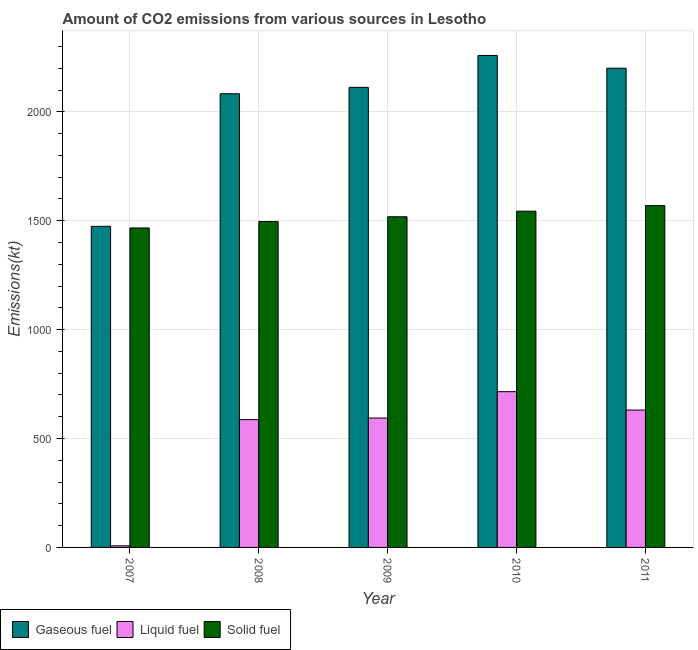How many different coloured bars are there?
Your response must be concise. 3. Are the number of bars on each tick of the X-axis equal?
Offer a very short reply. Yes. How many bars are there on the 2nd tick from the left?
Provide a succinct answer. 3. What is the label of the 3rd group of bars from the left?
Make the answer very short. 2009. In how many cases, is the number of bars for a given year not equal to the number of legend labels?
Offer a very short reply. 0. What is the amount of co2 emissions from gaseous fuel in 2010?
Ensure brevity in your answer.  2258.87. Across all years, what is the maximum amount of co2 emissions from gaseous fuel?
Offer a terse response. 2258.87. Across all years, what is the minimum amount of co2 emissions from solid fuel?
Keep it short and to the point. 1466.8. In which year was the amount of co2 emissions from solid fuel maximum?
Make the answer very short. 2011. What is the total amount of co2 emissions from liquid fuel in the graph?
Your answer should be very brief. 2533.9. What is the difference between the amount of co2 emissions from liquid fuel in 2007 and that in 2010?
Your answer should be very brief. -707.73. What is the difference between the amount of co2 emissions from liquid fuel in 2010 and the amount of co2 emissions from gaseous fuel in 2008?
Make the answer very short. 128.35. What is the average amount of co2 emissions from gaseous fuel per year?
Give a very brief answer. 2025.65. In the year 2008, what is the difference between the amount of co2 emissions from liquid fuel and amount of co2 emissions from solid fuel?
Your answer should be compact. 0. What is the ratio of the amount of co2 emissions from liquid fuel in 2007 to that in 2008?
Your answer should be very brief. 0.01. What is the difference between the highest and the second highest amount of co2 emissions from solid fuel?
Offer a very short reply. 25.67. What is the difference between the highest and the lowest amount of co2 emissions from gaseous fuel?
Provide a succinct answer. 784.74. Is the sum of the amount of co2 emissions from liquid fuel in 2008 and 2011 greater than the maximum amount of co2 emissions from gaseous fuel across all years?
Make the answer very short. Yes. What does the 3rd bar from the left in 2009 represents?
Offer a terse response. Solid fuel. What does the 3rd bar from the right in 2011 represents?
Ensure brevity in your answer.  Gaseous fuel. How many bars are there?
Your answer should be very brief. 15. Are all the bars in the graph horizontal?
Offer a terse response. No. What is the difference between two consecutive major ticks on the Y-axis?
Provide a short and direct response. 500. Does the graph contain any zero values?
Make the answer very short. No. Does the graph contain grids?
Provide a short and direct response. Yes. Where does the legend appear in the graph?
Make the answer very short. Bottom left. How are the legend labels stacked?
Provide a short and direct response. Horizontal. What is the title of the graph?
Offer a very short reply. Amount of CO2 emissions from various sources in Lesotho. Does "Non-communicable diseases" appear as one of the legend labels in the graph?
Offer a terse response. No. What is the label or title of the Y-axis?
Keep it short and to the point. Emissions(kt). What is the Emissions(kt) of Gaseous fuel in 2007?
Your answer should be compact. 1474.13. What is the Emissions(kt) of Liquid fuel in 2007?
Keep it short and to the point. 7.33. What is the Emissions(kt) in Solid fuel in 2007?
Provide a succinct answer. 1466.8. What is the Emissions(kt) in Gaseous fuel in 2008?
Keep it short and to the point. 2082.86. What is the Emissions(kt) in Liquid fuel in 2008?
Offer a terse response. 586.72. What is the Emissions(kt) of Solid fuel in 2008?
Provide a succinct answer. 1496.14. What is the Emissions(kt) in Gaseous fuel in 2009?
Your answer should be compact. 2112.19. What is the Emissions(kt) of Liquid fuel in 2009?
Your answer should be very brief. 594.05. What is the Emissions(kt) of Solid fuel in 2009?
Your answer should be compact. 1518.14. What is the Emissions(kt) of Gaseous fuel in 2010?
Give a very brief answer. 2258.87. What is the Emissions(kt) of Liquid fuel in 2010?
Your answer should be compact. 715.07. What is the Emissions(kt) of Solid fuel in 2010?
Provide a short and direct response. 1543.81. What is the Emissions(kt) of Gaseous fuel in 2011?
Offer a very short reply. 2200.2. What is the Emissions(kt) of Liquid fuel in 2011?
Give a very brief answer. 630.72. What is the Emissions(kt) of Solid fuel in 2011?
Provide a succinct answer. 1569.48. Across all years, what is the maximum Emissions(kt) in Gaseous fuel?
Make the answer very short. 2258.87. Across all years, what is the maximum Emissions(kt) of Liquid fuel?
Ensure brevity in your answer.  715.07. Across all years, what is the maximum Emissions(kt) in Solid fuel?
Provide a short and direct response. 1569.48. Across all years, what is the minimum Emissions(kt) of Gaseous fuel?
Your answer should be compact. 1474.13. Across all years, what is the minimum Emissions(kt) of Liquid fuel?
Offer a very short reply. 7.33. Across all years, what is the minimum Emissions(kt) in Solid fuel?
Ensure brevity in your answer.  1466.8. What is the total Emissions(kt) of Gaseous fuel in the graph?
Your answer should be very brief. 1.01e+04. What is the total Emissions(kt) of Liquid fuel in the graph?
Make the answer very short. 2533.9. What is the total Emissions(kt) of Solid fuel in the graph?
Provide a short and direct response. 7594.36. What is the difference between the Emissions(kt) of Gaseous fuel in 2007 and that in 2008?
Make the answer very short. -608.72. What is the difference between the Emissions(kt) of Liquid fuel in 2007 and that in 2008?
Offer a very short reply. -579.39. What is the difference between the Emissions(kt) in Solid fuel in 2007 and that in 2008?
Provide a short and direct response. -29.34. What is the difference between the Emissions(kt) in Gaseous fuel in 2007 and that in 2009?
Provide a succinct answer. -638.06. What is the difference between the Emissions(kt) of Liquid fuel in 2007 and that in 2009?
Your response must be concise. -586.72. What is the difference between the Emissions(kt) of Solid fuel in 2007 and that in 2009?
Make the answer very short. -51.34. What is the difference between the Emissions(kt) in Gaseous fuel in 2007 and that in 2010?
Give a very brief answer. -784.74. What is the difference between the Emissions(kt) in Liquid fuel in 2007 and that in 2010?
Your response must be concise. -707.73. What is the difference between the Emissions(kt) in Solid fuel in 2007 and that in 2010?
Provide a short and direct response. -77.01. What is the difference between the Emissions(kt) in Gaseous fuel in 2007 and that in 2011?
Make the answer very short. -726.07. What is the difference between the Emissions(kt) in Liquid fuel in 2007 and that in 2011?
Your response must be concise. -623.39. What is the difference between the Emissions(kt) of Solid fuel in 2007 and that in 2011?
Provide a succinct answer. -102.68. What is the difference between the Emissions(kt) of Gaseous fuel in 2008 and that in 2009?
Your answer should be compact. -29.34. What is the difference between the Emissions(kt) of Liquid fuel in 2008 and that in 2009?
Your response must be concise. -7.33. What is the difference between the Emissions(kt) of Solid fuel in 2008 and that in 2009?
Make the answer very short. -22. What is the difference between the Emissions(kt) in Gaseous fuel in 2008 and that in 2010?
Give a very brief answer. -176.02. What is the difference between the Emissions(kt) of Liquid fuel in 2008 and that in 2010?
Ensure brevity in your answer.  -128.34. What is the difference between the Emissions(kt) in Solid fuel in 2008 and that in 2010?
Keep it short and to the point. -47.67. What is the difference between the Emissions(kt) of Gaseous fuel in 2008 and that in 2011?
Ensure brevity in your answer.  -117.34. What is the difference between the Emissions(kt) of Liquid fuel in 2008 and that in 2011?
Make the answer very short. -44. What is the difference between the Emissions(kt) in Solid fuel in 2008 and that in 2011?
Your response must be concise. -73.34. What is the difference between the Emissions(kt) of Gaseous fuel in 2009 and that in 2010?
Provide a succinct answer. -146.68. What is the difference between the Emissions(kt) of Liquid fuel in 2009 and that in 2010?
Give a very brief answer. -121.01. What is the difference between the Emissions(kt) in Solid fuel in 2009 and that in 2010?
Ensure brevity in your answer.  -25.67. What is the difference between the Emissions(kt) of Gaseous fuel in 2009 and that in 2011?
Give a very brief answer. -88.01. What is the difference between the Emissions(kt) in Liquid fuel in 2009 and that in 2011?
Ensure brevity in your answer.  -36.67. What is the difference between the Emissions(kt) in Solid fuel in 2009 and that in 2011?
Provide a succinct answer. -51.34. What is the difference between the Emissions(kt) of Gaseous fuel in 2010 and that in 2011?
Provide a succinct answer. 58.67. What is the difference between the Emissions(kt) of Liquid fuel in 2010 and that in 2011?
Ensure brevity in your answer.  84.34. What is the difference between the Emissions(kt) of Solid fuel in 2010 and that in 2011?
Keep it short and to the point. -25.67. What is the difference between the Emissions(kt) of Gaseous fuel in 2007 and the Emissions(kt) of Liquid fuel in 2008?
Offer a terse response. 887.41. What is the difference between the Emissions(kt) of Gaseous fuel in 2007 and the Emissions(kt) of Solid fuel in 2008?
Ensure brevity in your answer.  -22. What is the difference between the Emissions(kt) in Liquid fuel in 2007 and the Emissions(kt) in Solid fuel in 2008?
Your response must be concise. -1488.8. What is the difference between the Emissions(kt) in Gaseous fuel in 2007 and the Emissions(kt) in Liquid fuel in 2009?
Provide a succinct answer. 880.08. What is the difference between the Emissions(kt) in Gaseous fuel in 2007 and the Emissions(kt) in Solid fuel in 2009?
Ensure brevity in your answer.  -44. What is the difference between the Emissions(kt) of Liquid fuel in 2007 and the Emissions(kt) of Solid fuel in 2009?
Provide a succinct answer. -1510.8. What is the difference between the Emissions(kt) of Gaseous fuel in 2007 and the Emissions(kt) of Liquid fuel in 2010?
Keep it short and to the point. 759.07. What is the difference between the Emissions(kt) in Gaseous fuel in 2007 and the Emissions(kt) in Solid fuel in 2010?
Provide a succinct answer. -69.67. What is the difference between the Emissions(kt) in Liquid fuel in 2007 and the Emissions(kt) in Solid fuel in 2010?
Provide a succinct answer. -1536.47. What is the difference between the Emissions(kt) of Gaseous fuel in 2007 and the Emissions(kt) of Liquid fuel in 2011?
Keep it short and to the point. 843.41. What is the difference between the Emissions(kt) of Gaseous fuel in 2007 and the Emissions(kt) of Solid fuel in 2011?
Provide a short and direct response. -95.34. What is the difference between the Emissions(kt) of Liquid fuel in 2007 and the Emissions(kt) of Solid fuel in 2011?
Your response must be concise. -1562.14. What is the difference between the Emissions(kt) of Gaseous fuel in 2008 and the Emissions(kt) of Liquid fuel in 2009?
Give a very brief answer. 1488.8. What is the difference between the Emissions(kt) of Gaseous fuel in 2008 and the Emissions(kt) of Solid fuel in 2009?
Your response must be concise. 564.72. What is the difference between the Emissions(kt) in Liquid fuel in 2008 and the Emissions(kt) in Solid fuel in 2009?
Ensure brevity in your answer.  -931.42. What is the difference between the Emissions(kt) in Gaseous fuel in 2008 and the Emissions(kt) in Liquid fuel in 2010?
Your answer should be compact. 1367.79. What is the difference between the Emissions(kt) of Gaseous fuel in 2008 and the Emissions(kt) of Solid fuel in 2010?
Provide a succinct answer. 539.05. What is the difference between the Emissions(kt) in Liquid fuel in 2008 and the Emissions(kt) in Solid fuel in 2010?
Your answer should be compact. -957.09. What is the difference between the Emissions(kt) of Gaseous fuel in 2008 and the Emissions(kt) of Liquid fuel in 2011?
Ensure brevity in your answer.  1452.13. What is the difference between the Emissions(kt) in Gaseous fuel in 2008 and the Emissions(kt) in Solid fuel in 2011?
Your response must be concise. 513.38. What is the difference between the Emissions(kt) of Liquid fuel in 2008 and the Emissions(kt) of Solid fuel in 2011?
Your answer should be very brief. -982.76. What is the difference between the Emissions(kt) in Gaseous fuel in 2009 and the Emissions(kt) in Liquid fuel in 2010?
Make the answer very short. 1397.13. What is the difference between the Emissions(kt) of Gaseous fuel in 2009 and the Emissions(kt) of Solid fuel in 2010?
Your answer should be compact. 568.38. What is the difference between the Emissions(kt) in Liquid fuel in 2009 and the Emissions(kt) in Solid fuel in 2010?
Offer a terse response. -949.75. What is the difference between the Emissions(kt) of Gaseous fuel in 2009 and the Emissions(kt) of Liquid fuel in 2011?
Your answer should be very brief. 1481.47. What is the difference between the Emissions(kt) of Gaseous fuel in 2009 and the Emissions(kt) of Solid fuel in 2011?
Ensure brevity in your answer.  542.72. What is the difference between the Emissions(kt) in Liquid fuel in 2009 and the Emissions(kt) in Solid fuel in 2011?
Your response must be concise. -975.42. What is the difference between the Emissions(kt) in Gaseous fuel in 2010 and the Emissions(kt) in Liquid fuel in 2011?
Make the answer very short. 1628.15. What is the difference between the Emissions(kt) in Gaseous fuel in 2010 and the Emissions(kt) in Solid fuel in 2011?
Provide a short and direct response. 689.4. What is the difference between the Emissions(kt) of Liquid fuel in 2010 and the Emissions(kt) of Solid fuel in 2011?
Make the answer very short. -854.41. What is the average Emissions(kt) in Gaseous fuel per year?
Keep it short and to the point. 2025.65. What is the average Emissions(kt) in Liquid fuel per year?
Provide a short and direct response. 506.78. What is the average Emissions(kt) in Solid fuel per year?
Provide a short and direct response. 1518.87. In the year 2007, what is the difference between the Emissions(kt) of Gaseous fuel and Emissions(kt) of Liquid fuel?
Your answer should be compact. 1466.8. In the year 2007, what is the difference between the Emissions(kt) of Gaseous fuel and Emissions(kt) of Solid fuel?
Keep it short and to the point. 7.33. In the year 2007, what is the difference between the Emissions(kt) of Liquid fuel and Emissions(kt) of Solid fuel?
Your response must be concise. -1459.47. In the year 2008, what is the difference between the Emissions(kt) in Gaseous fuel and Emissions(kt) in Liquid fuel?
Give a very brief answer. 1496.14. In the year 2008, what is the difference between the Emissions(kt) of Gaseous fuel and Emissions(kt) of Solid fuel?
Keep it short and to the point. 586.72. In the year 2008, what is the difference between the Emissions(kt) of Liquid fuel and Emissions(kt) of Solid fuel?
Make the answer very short. -909.42. In the year 2009, what is the difference between the Emissions(kt) of Gaseous fuel and Emissions(kt) of Liquid fuel?
Your answer should be very brief. 1518.14. In the year 2009, what is the difference between the Emissions(kt) of Gaseous fuel and Emissions(kt) of Solid fuel?
Provide a succinct answer. 594.05. In the year 2009, what is the difference between the Emissions(kt) of Liquid fuel and Emissions(kt) of Solid fuel?
Your answer should be compact. -924.08. In the year 2010, what is the difference between the Emissions(kt) in Gaseous fuel and Emissions(kt) in Liquid fuel?
Give a very brief answer. 1543.81. In the year 2010, what is the difference between the Emissions(kt) of Gaseous fuel and Emissions(kt) of Solid fuel?
Offer a terse response. 715.07. In the year 2010, what is the difference between the Emissions(kt) of Liquid fuel and Emissions(kt) of Solid fuel?
Keep it short and to the point. -828.74. In the year 2011, what is the difference between the Emissions(kt) of Gaseous fuel and Emissions(kt) of Liquid fuel?
Your response must be concise. 1569.48. In the year 2011, what is the difference between the Emissions(kt) in Gaseous fuel and Emissions(kt) in Solid fuel?
Make the answer very short. 630.72. In the year 2011, what is the difference between the Emissions(kt) in Liquid fuel and Emissions(kt) in Solid fuel?
Your answer should be very brief. -938.75. What is the ratio of the Emissions(kt) in Gaseous fuel in 2007 to that in 2008?
Provide a succinct answer. 0.71. What is the ratio of the Emissions(kt) in Liquid fuel in 2007 to that in 2008?
Offer a very short reply. 0.01. What is the ratio of the Emissions(kt) of Solid fuel in 2007 to that in 2008?
Your answer should be compact. 0.98. What is the ratio of the Emissions(kt) in Gaseous fuel in 2007 to that in 2009?
Your answer should be very brief. 0.7. What is the ratio of the Emissions(kt) in Liquid fuel in 2007 to that in 2009?
Your response must be concise. 0.01. What is the ratio of the Emissions(kt) in Solid fuel in 2007 to that in 2009?
Offer a terse response. 0.97. What is the ratio of the Emissions(kt) of Gaseous fuel in 2007 to that in 2010?
Your answer should be compact. 0.65. What is the ratio of the Emissions(kt) in Liquid fuel in 2007 to that in 2010?
Offer a terse response. 0.01. What is the ratio of the Emissions(kt) of Solid fuel in 2007 to that in 2010?
Provide a succinct answer. 0.95. What is the ratio of the Emissions(kt) in Gaseous fuel in 2007 to that in 2011?
Give a very brief answer. 0.67. What is the ratio of the Emissions(kt) in Liquid fuel in 2007 to that in 2011?
Make the answer very short. 0.01. What is the ratio of the Emissions(kt) of Solid fuel in 2007 to that in 2011?
Provide a short and direct response. 0.93. What is the ratio of the Emissions(kt) in Gaseous fuel in 2008 to that in 2009?
Keep it short and to the point. 0.99. What is the ratio of the Emissions(kt) in Liquid fuel in 2008 to that in 2009?
Ensure brevity in your answer.  0.99. What is the ratio of the Emissions(kt) in Solid fuel in 2008 to that in 2009?
Offer a terse response. 0.99. What is the ratio of the Emissions(kt) of Gaseous fuel in 2008 to that in 2010?
Your response must be concise. 0.92. What is the ratio of the Emissions(kt) of Liquid fuel in 2008 to that in 2010?
Provide a succinct answer. 0.82. What is the ratio of the Emissions(kt) in Solid fuel in 2008 to that in 2010?
Offer a terse response. 0.97. What is the ratio of the Emissions(kt) of Gaseous fuel in 2008 to that in 2011?
Keep it short and to the point. 0.95. What is the ratio of the Emissions(kt) of Liquid fuel in 2008 to that in 2011?
Offer a terse response. 0.93. What is the ratio of the Emissions(kt) of Solid fuel in 2008 to that in 2011?
Provide a short and direct response. 0.95. What is the ratio of the Emissions(kt) of Gaseous fuel in 2009 to that in 2010?
Give a very brief answer. 0.94. What is the ratio of the Emissions(kt) of Liquid fuel in 2009 to that in 2010?
Give a very brief answer. 0.83. What is the ratio of the Emissions(kt) in Solid fuel in 2009 to that in 2010?
Offer a terse response. 0.98. What is the ratio of the Emissions(kt) of Gaseous fuel in 2009 to that in 2011?
Give a very brief answer. 0.96. What is the ratio of the Emissions(kt) of Liquid fuel in 2009 to that in 2011?
Offer a terse response. 0.94. What is the ratio of the Emissions(kt) in Solid fuel in 2009 to that in 2011?
Make the answer very short. 0.97. What is the ratio of the Emissions(kt) in Gaseous fuel in 2010 to that in 2011?
Provide a succinct answer. 1.03. What is the ratio of the Emissions(kt) in Liquid fuel in 2010 to that in 2011?
Keep it short and to the point. 1.13. What is the ratio of the Emissions(kt) of Solid fuel in 2010 to that in 2011?
Offer a very short reply. 0.98. What is the difference between the highest and the second highest Emissions(kt) of Gaseous fuel?
Offer a terse response. 58.67. What is the difference between the highest and the second highest Emissions(kt) of Liquid fuel?
Your answer should be very brief. 84.34. What is the difference between the highest and the second highest Emissions(kt) in Solid fuel?
Make the answer very short. 25.67. What is the difference between the highest and the lowest Emissions(kt) in Gaseous fuel?
Your response must be concise. 784.74. What is the difference between the highest and the lowest Emissions(kt) in Liquid fuel?
Make the answer very short. 707.73. What is the difference between the highest and the lowest Emissions(kt) in Solid fuel?
Keep it short and to the point. 102.68. 